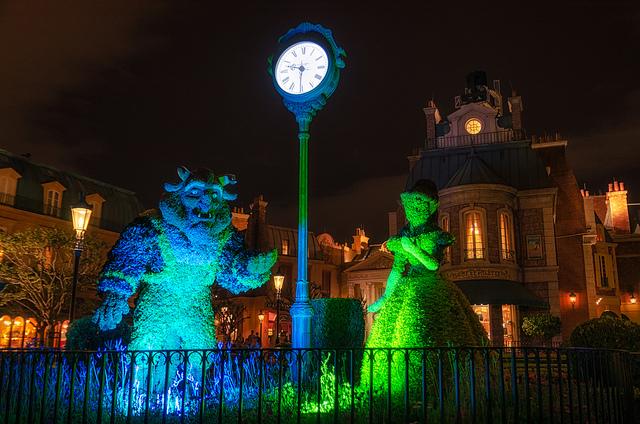Which theme park would have this display?
Be succinct. Disney. What are the bushes shaped like?
Keep it brief. Beauty and beast. What color is the bush on left?
Be succinct. Blue. 